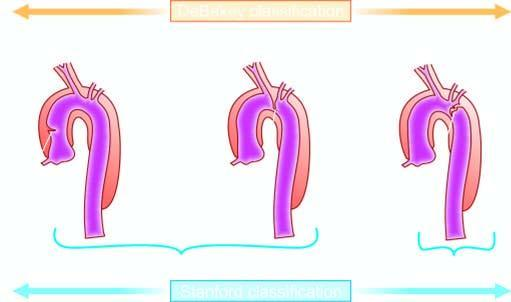does esions include includes debakey 's type i and ii?
Answer the question using a single word or phrase. No 